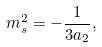<formula> <loc_0><loc_0><loc_500><loc_500>m _ { s } ^ { 2 } = - \frac { 1 } { 3 a _ { 2 } } ,</formula> 